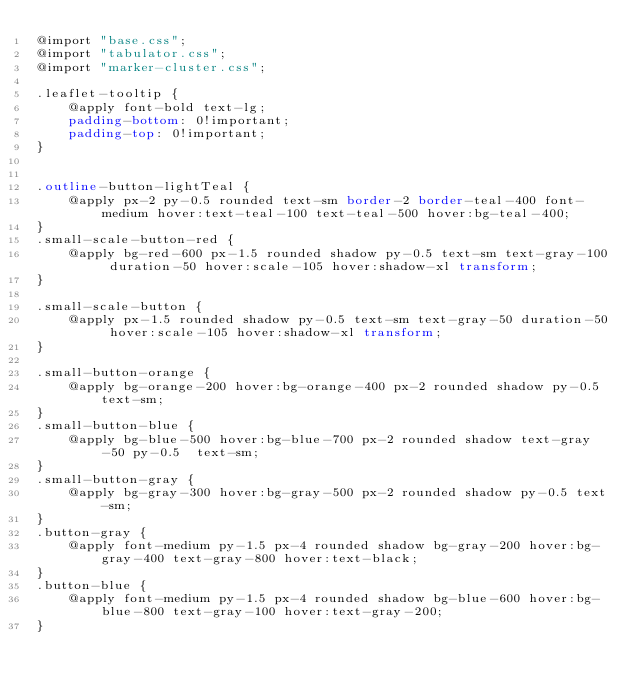Convert code to text. <code><loc_0><loc_0><loc_500><loc_500><_CSS_>@import "base.css";
@import "tabulator.css";
@import "marker-cluster.css";

.leaflet-tooltip {
    @apply font-bold text-lg;
    padding-bottom: 0!important;
    padding-top: 0!important;
}


.outline-button-lightTeal {
    @apply px-2 py-0.5 rounded text-sm border-2 border-teal-400 font-medium hover:text-teal-100 text-teal-500 hover:bg-teal-400;
}
.small-scale-button-red {
    @apply bg-red-600 px-1.5 rounded shadow py-0.5 text-sm text-gray-100 duration-50 hover:scale-105 hover:shadow-xl transform;
}

.small-scale-button {
    @apply px-1.5 rounded shadow py-0.5 text-sm text-gray-50 duration-50 hover:scale-105 hover:shadow-xl transform;
}

.small-button-orange {
    @apply bg-orange-200 hover:bg-orange-400 px-2 rounded shadow py-0.5 text-sm;
}
.small-button-blue {
    @apply bg-blue-500 hover:bg-blue-700 px-2 rounded shadow text-gray-50 py-0.5  text-sm;
}
.small-button-gray {
    @apply bg-gray-300 hover:bg-gray-500 px-2 rounded shadow py-0.5 text-sm;
}
.button-gray {
    @apply font-medium py-1.5 px-4 rounded shadow bg-gray-200 hover:bg-gray-400 text-gray-800 hover:text-black;
}
.button-blue {
    @apply font-medium py-1.5 px-4 rounded shadow bg-blue-600 hover:bg-blue-800 text-gray-100 hover:text-gray-200;
}

</code> 